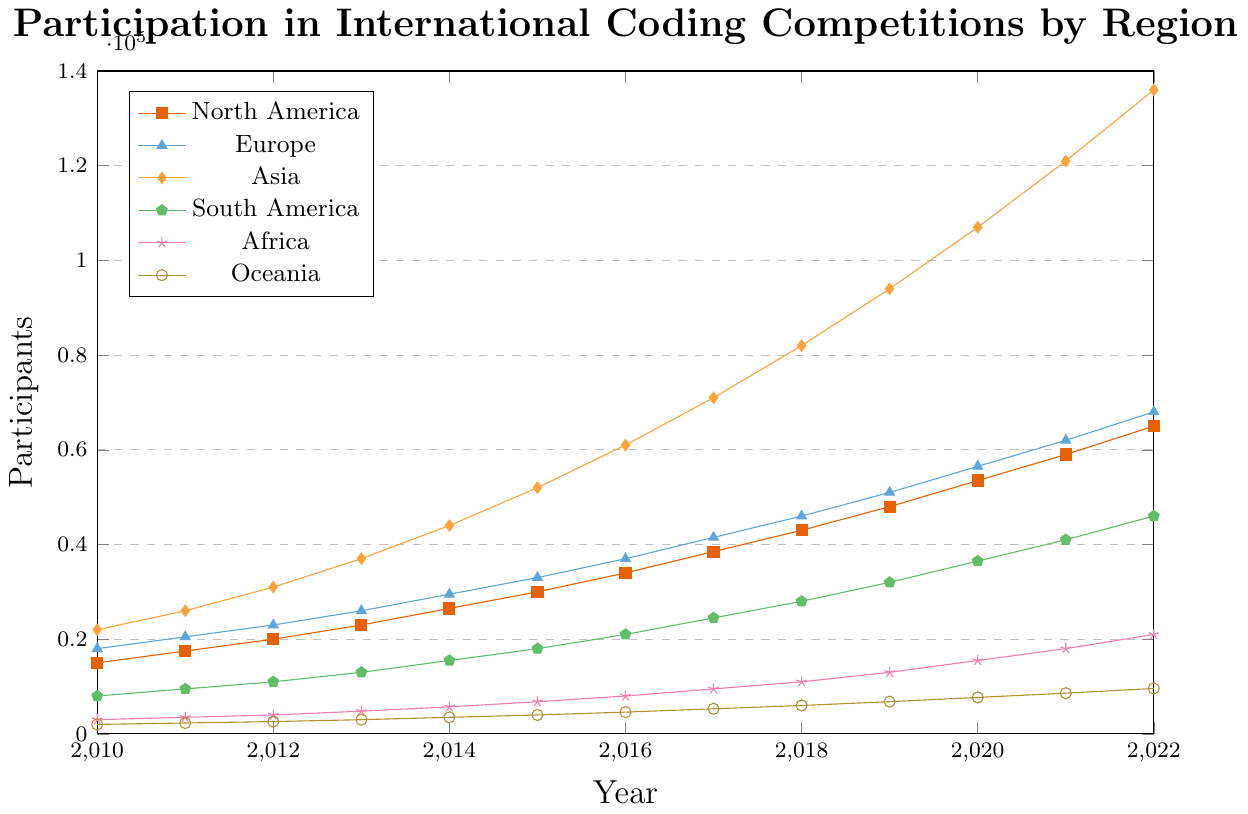Which region has the highest participation in 2022? To determine this, check the y-values for each region in 2022 and find the maximum. Asia has the highest participation with 136,000 participants.
Answer: Asia How many more participants did Europe have in 2022 compared to 2010? Find the difference in the number of participants between 2022 and 2010 for Europe. In 2022, Europe had 68,000 participants, and in 2010 it had 18,000. The difference is 68,000 - 18,000 = 50,000.
Answer: 50,000 Which region showed the largest increase in participation from 2010 to 2022? Calculate the increase for each region by subtracting the 2010 value from the 2022 value and compare them. Asia increased by 136,000 - 22,000 = 114,000, which is the largest.
Answer: Asia What is the average number of participants for North America over the years 2010 to 2022? Sum the participants for North America from 2010 to 2022 and divide by the number of years. The total is 15000+17500+20000+23000+26500+30000+34000+38500+43000+48000+53500+59000+65000=502000. There are 13 years, so 502000 / 13 = 38,615.
Answer: 38,615 Which region had the smallest participation in 2015 and how many participants did it have? Identify the smallest y-value in 2015 across all regions. Oceania had the smallest participation with 4,000 participants.
Answer: Oceania, 4,000 Compare the trend of participation between Africa and South America between 2010 and 2022. Which one had a steeper growth? Evaluate how rapidly each region's participation increased from 2010 to 2022. Africa increased from 3,000 to 21,000 (18,000 total increase), and South America increased from 8,000 to 46,000 (38,000 total increase). South America had a steeper growth.
Answer: South America What is the difference in participation between Asia and Oceania in 2020? Look at the number of participants for Asia and Oceania in 2020. Asia had 107,000 and Oceania had 7,700. The difference is 107,000 - 7,700 = 99,300.
Answer: 99,300 Which regions show a consistent increase in participants every year from 2010 to 2022? Review the line trends for each region to see if the number of participants increases every year without any declines. All regions show a consistent increase.
Answer: All regions How many total participants were there in 2018 across all regions? Sum the number of participants for all regions in 2018. 43,000 (North America) + 46,000 (Europe) + 82,000 (Asia) + 28,000 (South America) + 11,000 (Africa) + 6,000 (Oceania) = 216,000.
Answer: 216,000 